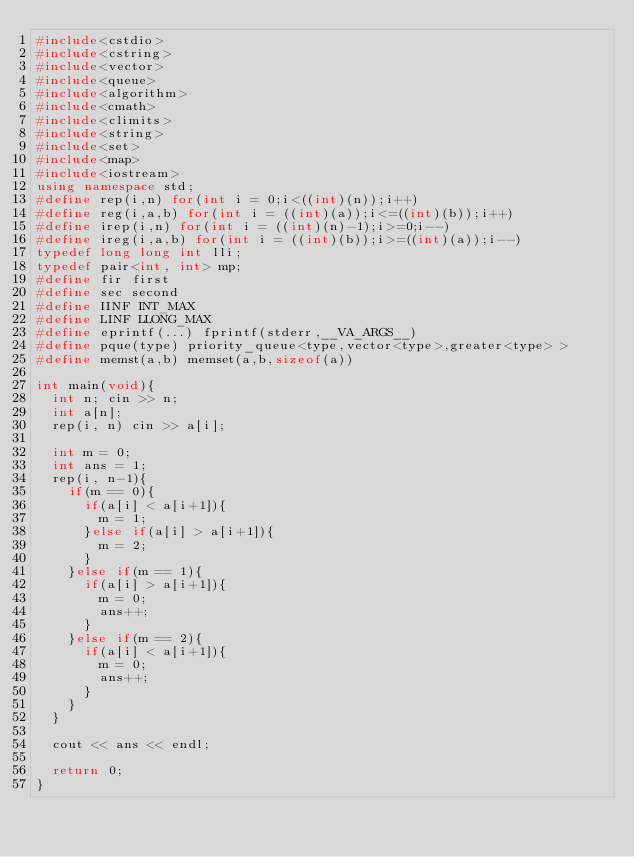<code> <loc_0><loc_0><loc_500><loc_500><_C++_>#include<cstdio>
#include<cstring>
#include<vector>
#include<queue>
#include<algorithm>
#include<cmath>
#include<climits>
#include<string>
#include<set>
#include<map>
#include<iostream>
using namespace std;
#define rep(i,n) for(int i = 0;i<((int)(n));i++)
#define reg(i,a,b) for(int i = ((int)(a));i<=((int)(b));i++)
#define irep(i,n) for(int i = ((int)(n)-1);i>=0;i--)
#define ireg(i,a,b) for(int i = ((int)(b));i>=((int)(a));i--)
typedef long long int lli;
typedef pair<int, int> mp;
#define fir first
#define sec second
#define IINF INT_MAX
#define LINF LLONG_MAX
#define eprintf(...) fprintf(stderr,__VA_ARGS__)
#define pque(type) priority_queue<type,vector<type>,greater<type> >
#define memst(a,b) memset(a,b,sizeof(a))
 
int main(void){
	int n; cin >> n;
	int a[n];
	rep(i, n) cin >> a[i];
	
	int m = 0;
	int ans = 1;
	rep(i, n-1){
		if(m == 0){
			if(a[i] < a[i+1]){
				m = 1;
			}else if(a[i] > a[i+1]){
				m = 2;
			}
		}else if(m == 1){
			if(a[i] > a[i+1]){
				m = 0;
				ans++;
			}
		}else if(m == 2){
			if(a[i] < a[i+1]){
				m = 0;
				ans++;
			}
		}
	}
	
	cout << ans << endl;
	
	return 0;
}</code> 